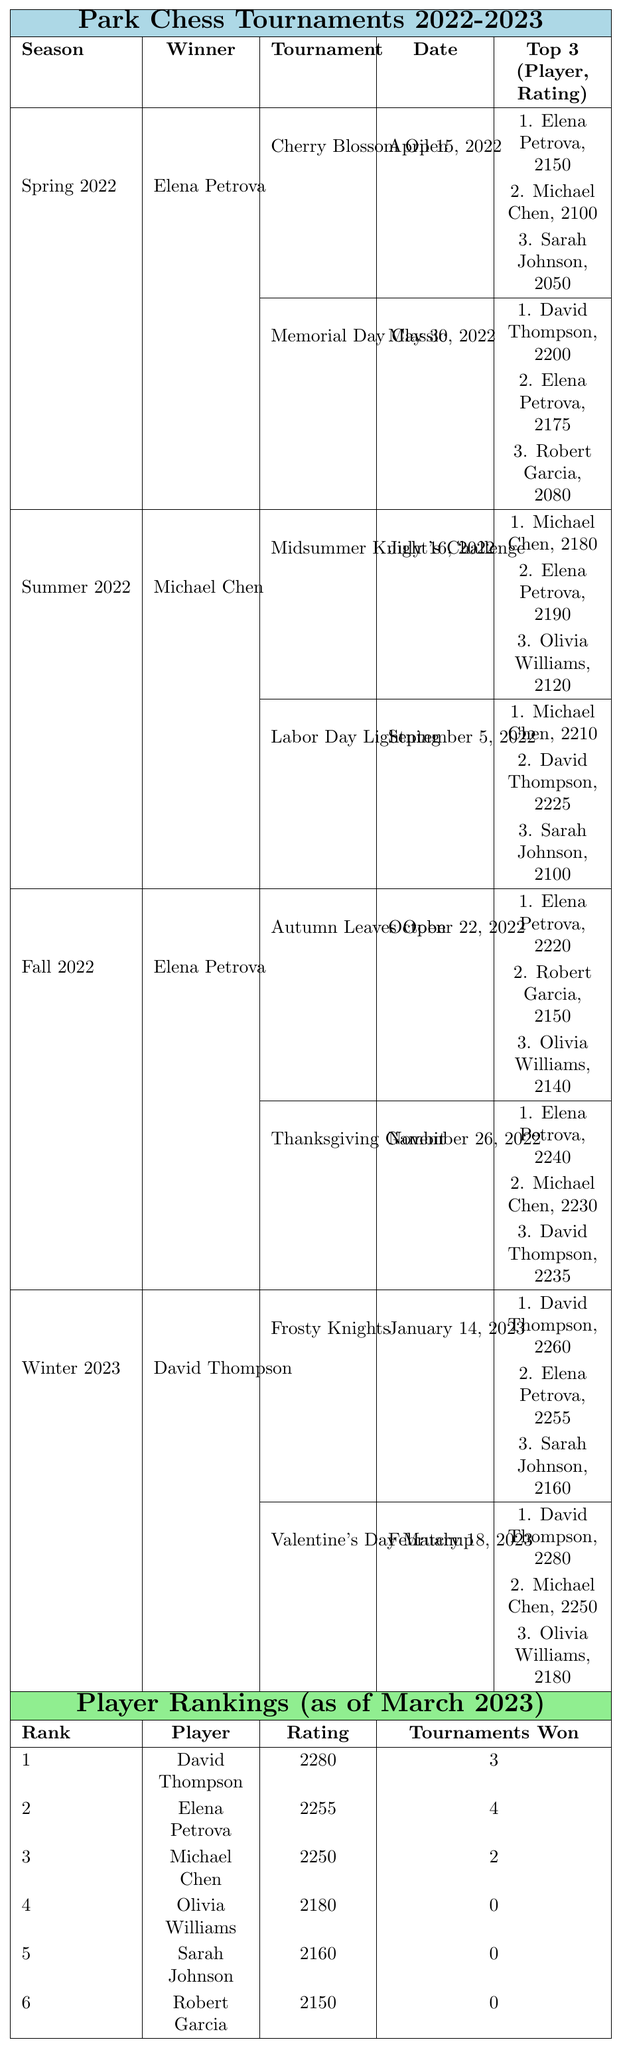What player won the 'Thanksgiving Gambit'? The table lists the tournaments and their winners. In the Fall 2022 season, under the 'Thanksgiving Gambit' tournament, it states that Elena Petrova won.
Answer: Elena Petrova Who had the highest rating in the Spring 2022 season? Looking at the Spring 2022 tournaments, the top ratings are 2150 for Elena Petrova, 2100 for Michael Chen, and 2050 for Sarah Johnson. Therefore, Elena Petrova had the highest rating in that season.
Answer: Elena Petrova How many tournaments did Elena Petrova win overall? The rankings table shows that Elena Petrova won 4 tournaments total, which is mentioned directly in the "Tournaments Won" column for her.
Answer: 4 Which tournament had the fewest participants? By examining the 'Participants' column in the tournament listings, the 'Frosty Knights' tournament had 22 participants, which is the lowest number across all listed tournaments.
Answer: Frosty Knights What is the difference in ratings between David Thompson and Michael Chen? David Thompson's rating is listed as 2280 while Michael Chen's is 2250. The difference is calculated as 2280 - 2250, which equals 30.
Answer: 30 Did Elena Petrova participate in the Labor Day Lightning tournament? The Labor Day Lightning tournament from Summer 2022 lists Michael Chen, David Thompson, and Sarah Johnson in the top 3, but Elena Petrova is not mentioned, indicating she did not participate.
Answer: No Which season had more tournaments: Summer 2022 or Winter 2023? Summer 2022 has 2 tournaments listed (Midsummer Knight's Challenge and Labor Day Lightning) and Winter 2023 also has 2 tournaments (Frosty Knights and Valentine's Day Matchup). Therefore, both seasons had an equal number of tournaments.
Answer: Equal Who was the winner of the most recent tournament listed? The most recent tournament listed in Winter 2023 is the 'Valentine's Day Matchup', which was won by David Thompson.
Answer: David Thompson What is the average rating of the top three players as of March 2023? The top three players have the ratings of 2280 (David Thompson), 2255 (Elena Petrova), and 2250 (Michael Chen). The sum of these ratings is 2280 + 2255 + 2250 = 6785. The average is calculated as 6785 / 3 = 2261.67.
Answer: 2261.67 Is it true that Michael Chen has more tournament wins than Sarah Johnson? Based on the table, Michael Chen has 2 tournament wins while Sarah Johnson has 0, so it is true that Michael Chen has more wins.
Answer: Yes 